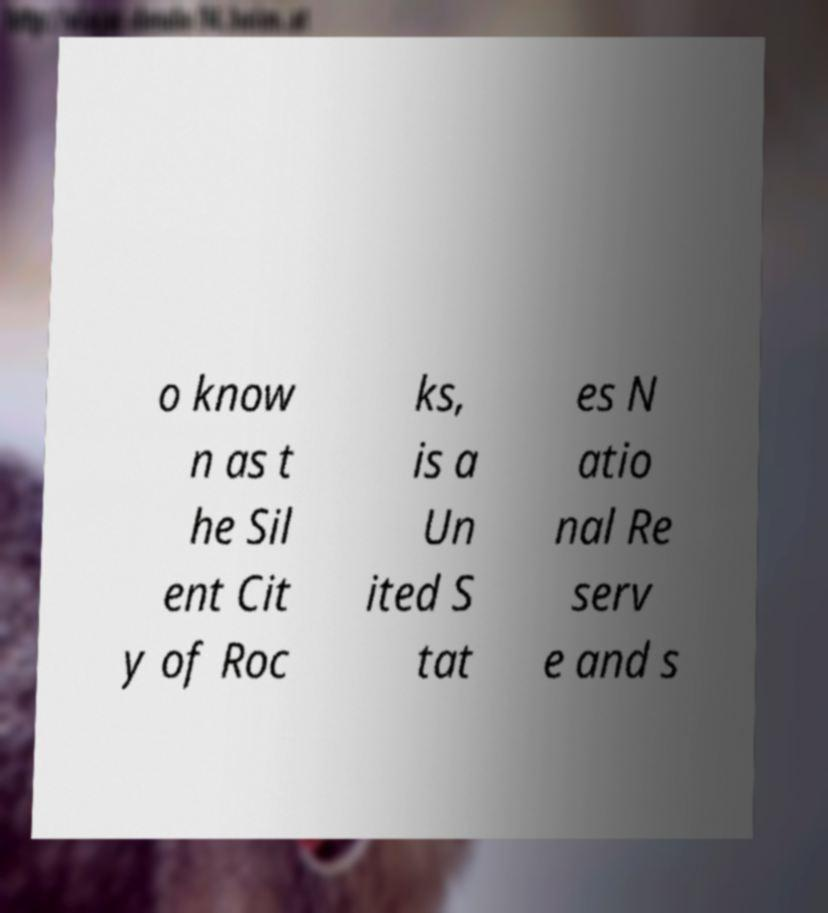Please identify and transcribe the text found in this image. o know n as t he Sil ent Cit y of Roc ks, is a Un ited S tat es N atio nal Re serv e and s 